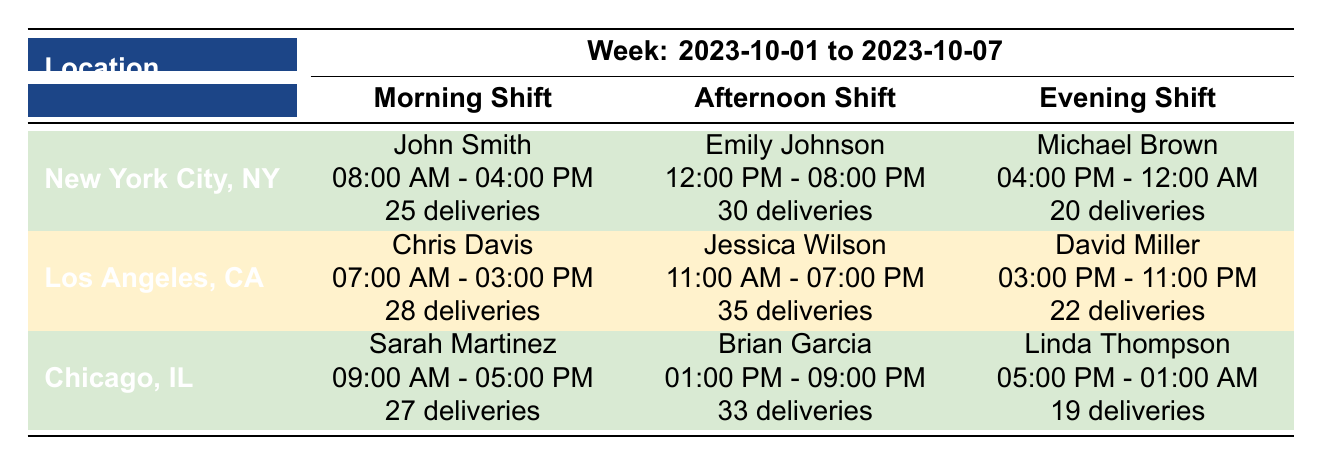What is the total number of deliveries made by drivers in New York City? In the New York City section, the total deliveries are 25 (John Smith) + 30 (Emily Johnson) + 20 (Michael Brown) = 75 deliveries.
Answer: 75 Which driver worked the evening shift in Chicago? From the Chicago section, Linda Thompson worked the evening shift from 5:00 PM to 1:00 AM.
Answer: Linda Thompson Did any driver in Los Angeles make more than 30 deliveries? Yes, Jessica Wilson made 35 deliveries, which is more than 30.
Answer: Yes What is the average number of deliveries made by drivers across all locations? In New York City, the total is 75; in Los Angeles, it is 85 (28 + 35 + 22); in Chicago, it is 79 (27 + 33 + 19). Summing these gives 75 + 85 + 79 = 239 deliveries total. Dividing by the number of drivers (3 in each location, so 9 total) gives an average of 239 / 9 ≈ 26.56 deliveries per driver.
Answer: Approximately 26.56 Which location had the highest total deliveries? New York City had 75 deliveries, Los Angeles had 85 deliveries, and Chicago had 79 deliveries. Since 85 is the highest, Los Angeles had the highest total deliveries.
Answer: Los Angeles How many deliveries did Michael Brown make? Michael Brown made 20 deliveries during his shift in New York City.
Answer: 20 Which driver in Chicago had the most deliveries? Brian Garcia had the most deliveries with 33, compared to Sarah Martinez (27) and Linda Thompson (19).
Answer: Brian Garcia Is there a driver who worked both the morning shift in New York City and had 25 or more deliveries? Yes, John Smith worked the morning shift and made 25 deliveries.
Answer: Yes 